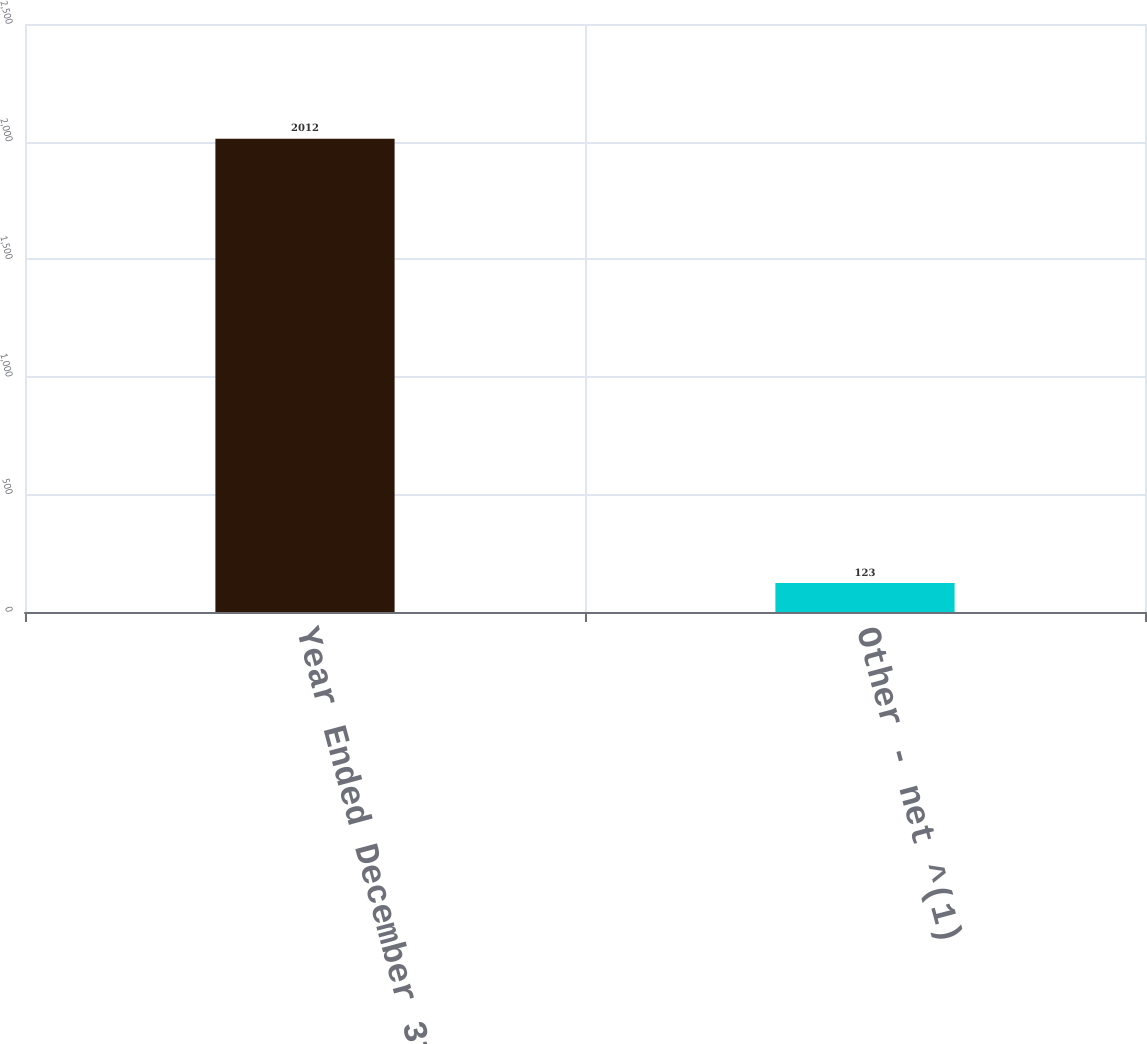Convert chart. <chart><loc_0><loc_0><loc_500><loc_500><bar_chart><fcel>Year Ended December 31<fcel>Other - net ^(1)<nl><fcel>2012<fcel>123<nl></chart> 